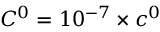Convert formula to latex. <formula><loc_0><loc_0><loc_500><loc_500>C ^ { 0 } = 1 0 ^ { - 7 } \times c ^ { 0 }</formula> 